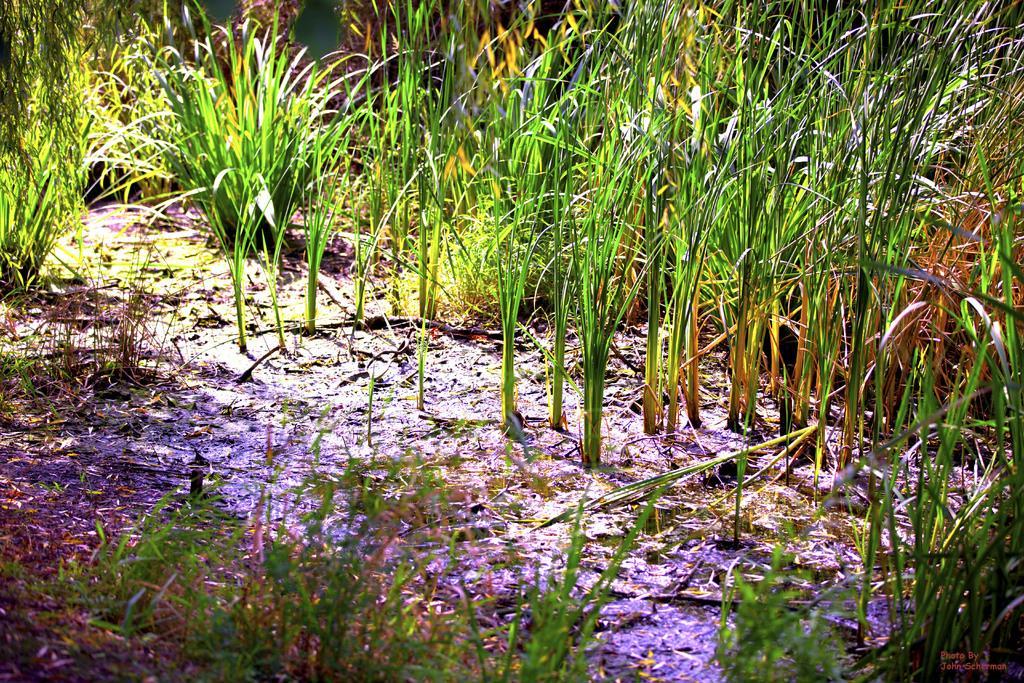In one or two sentences, can you explain what this image depicts? In this picture we can see planets on the ground. 